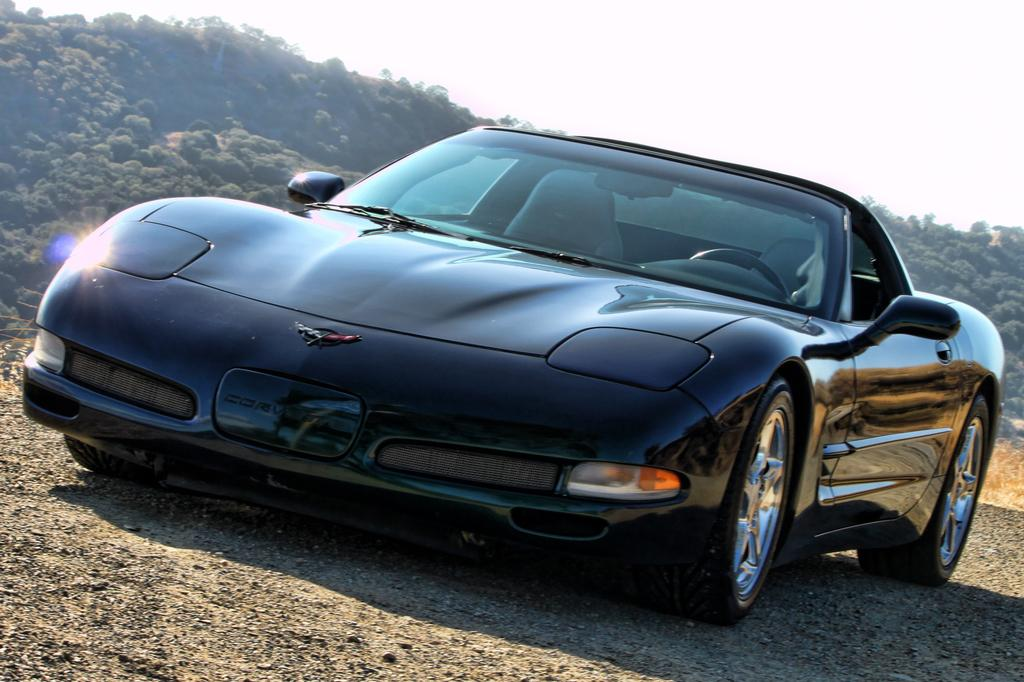What is the main subject of the image? There is a car in the image. What can be seen in the background of the image? There are hills, trees, and the sky visible in the background of the image. What type of salt is being used to season the car in the image? There is no salt present in the image, and the car is not being seasoned. 